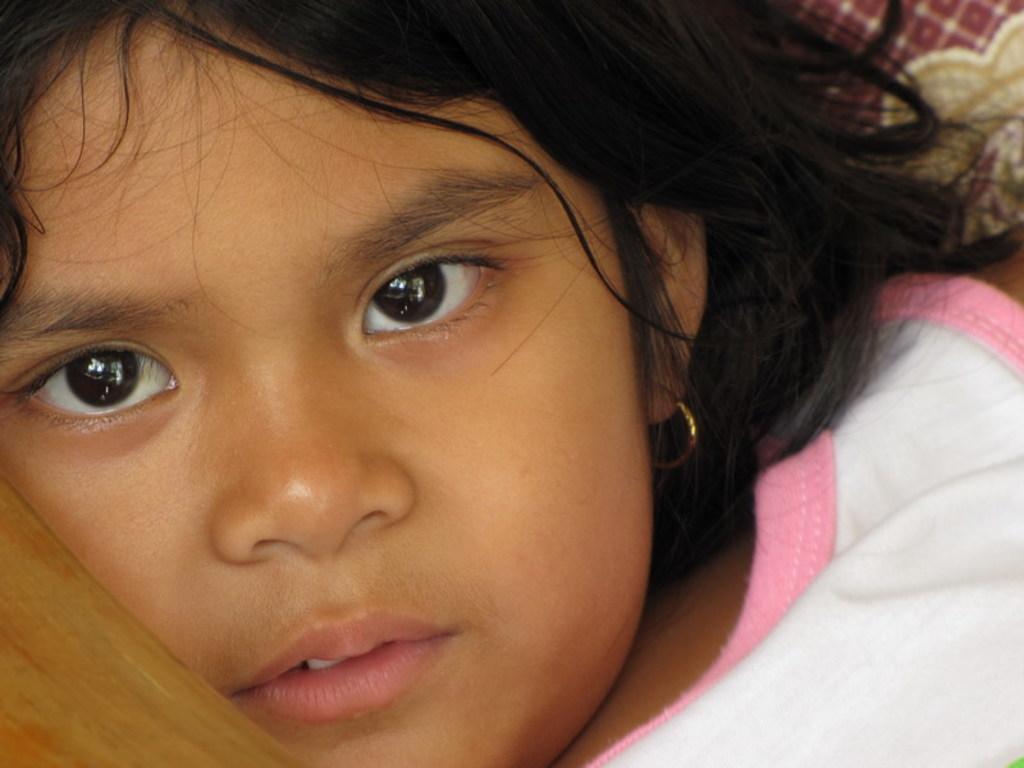Please provide a concise description of this image. In this picture there is a girl wearing a white top and a earring. 